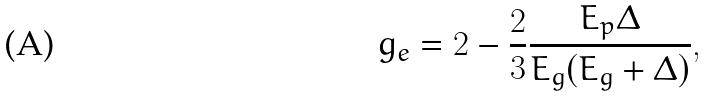<formula> <loc_0><loc_0><loc_500><loc_500>g _ { e } = 2 - \frac { 2 } { 3 } \frac { E _ { p } \Delta } { E _ { g } ( E _ { g } + \Delta ) } ,</formula> 